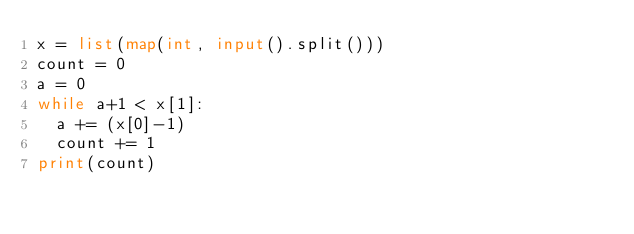Convert code to text. <code><loc_0><loc_0><loc_500><loc_500><_Python_>x = list(map(int, input().split()))
count = 0
a = 0
while a+1 < x[1]:
  a += (x[0]-1)
  count += 1
print(count)</code> 